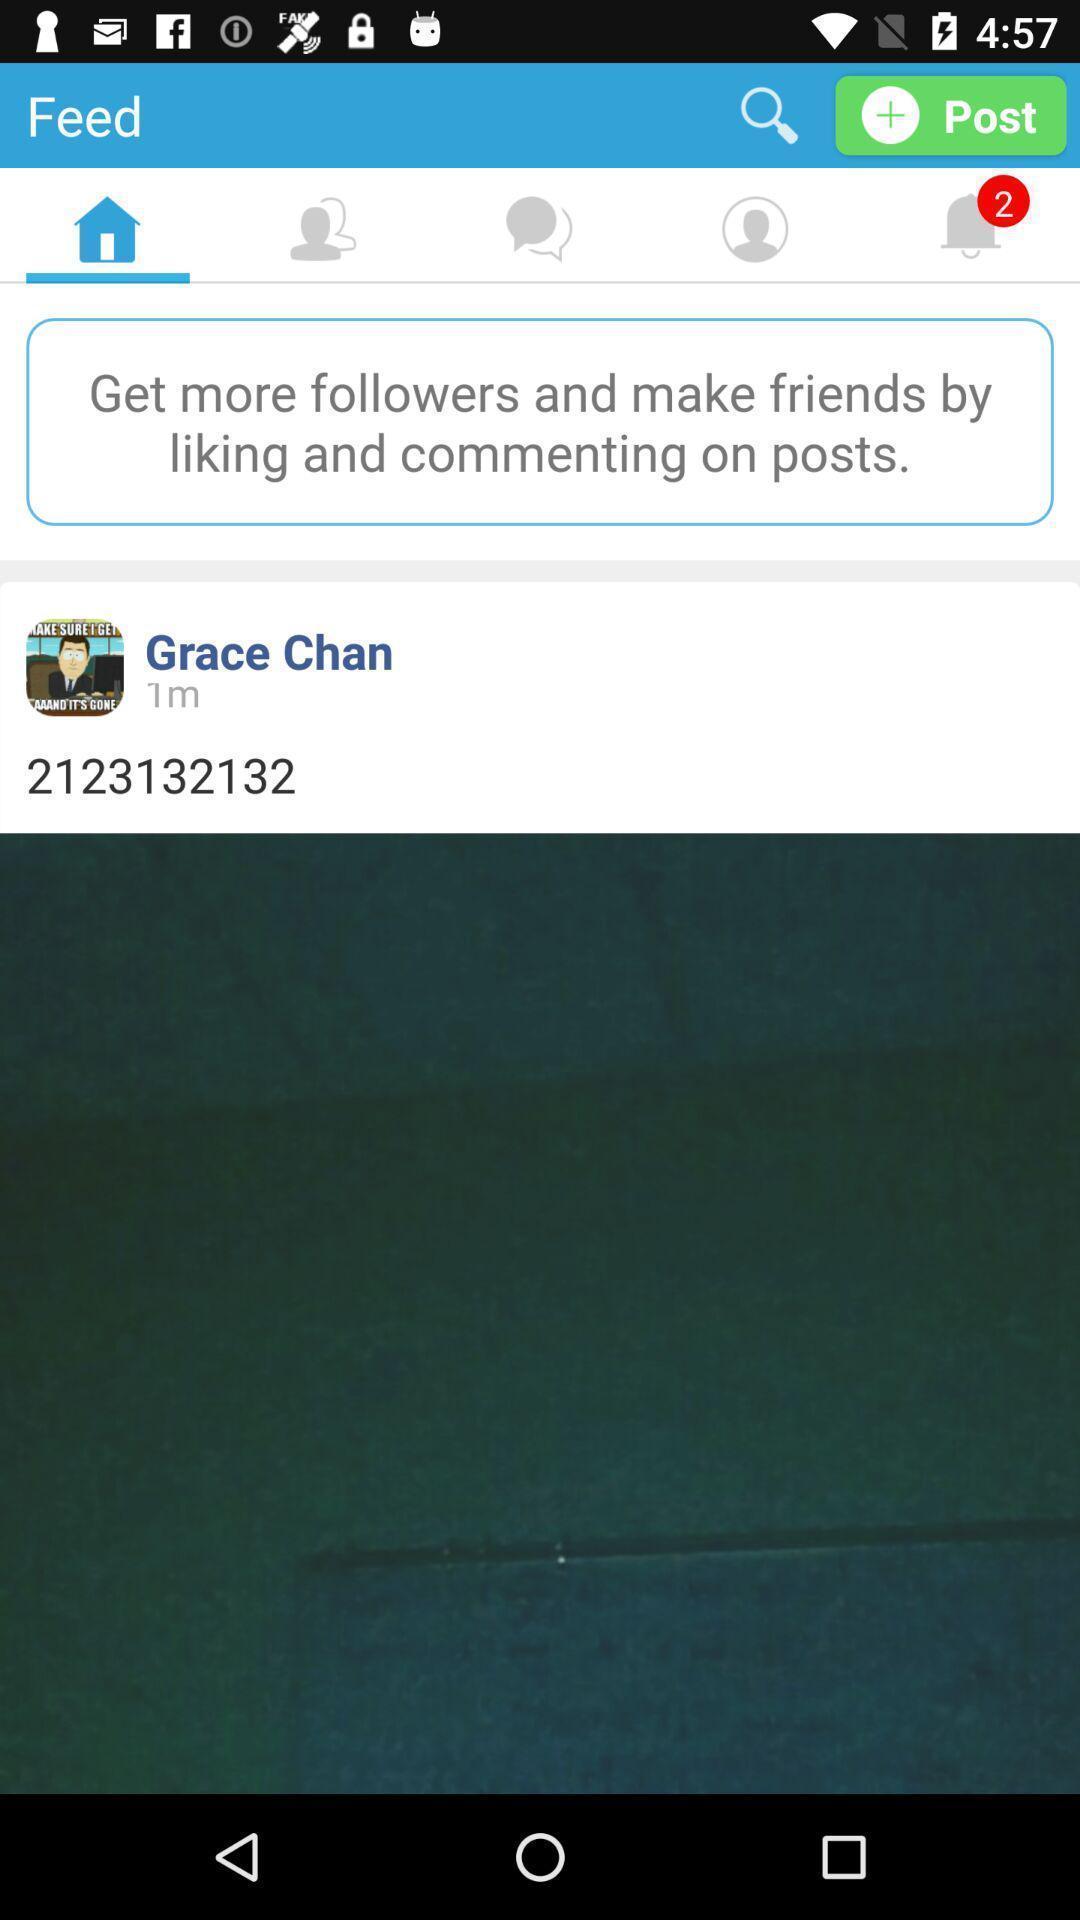Give me a summary of this screen capture. Page displaying the friends followers through posts. 